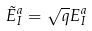<formula> <loc_0><loc_0><loc_500><loc_500>\tilde { E } _ { I } ^ { a } = \sqrt { q } E _ { I } ^ { a }</formula> 